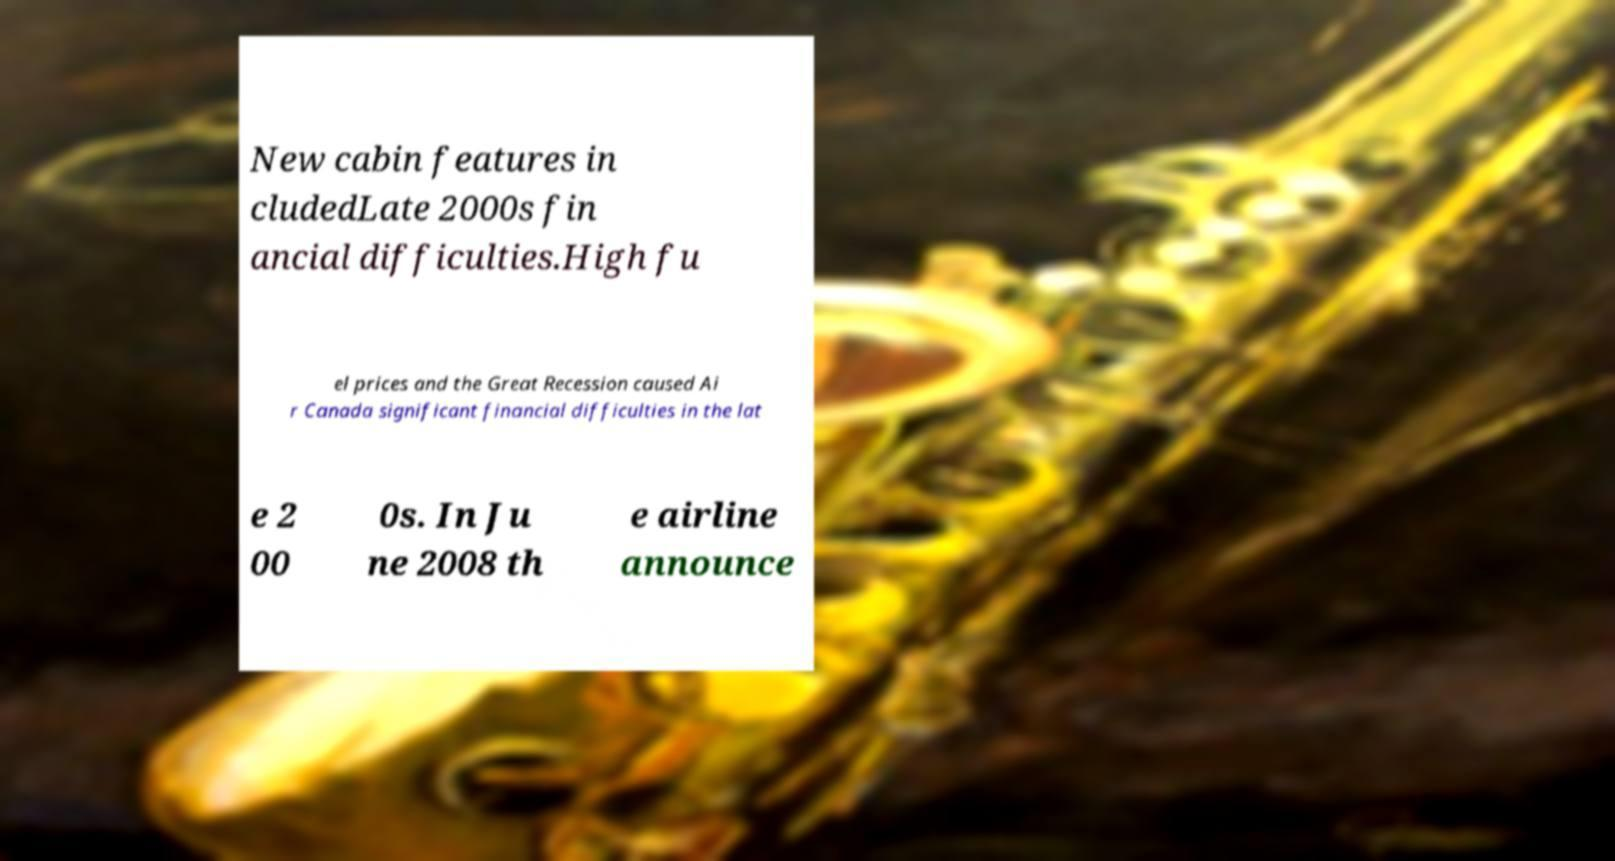For documentation purposes, I need the text within this image transcribed. Could you provide that? New cabin features in cludedLate 2000s fin ancial difficulties.High fu el prices and the Great Recession caused Ai r Canada significant financial difficulties in the lat e 2 00 0s. In Ju ne 2008 th e airline announce 